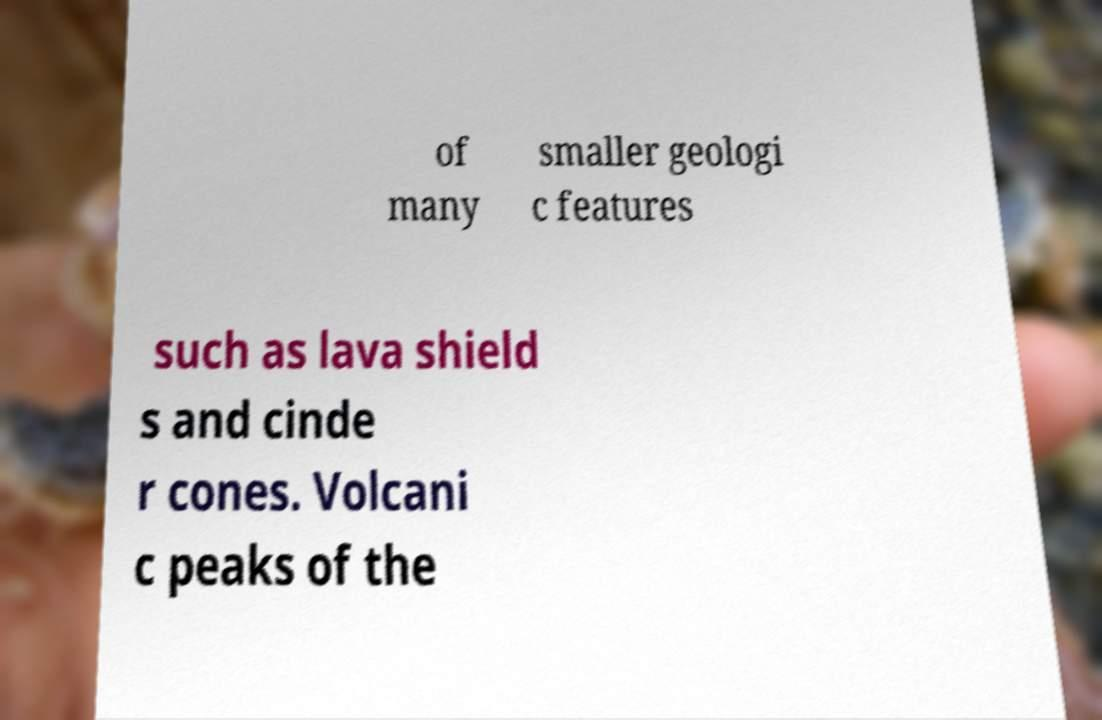Can you read and provide the text displayed in the image?This photo seems to have some interesting text. Can you extract and type it out for me? of many smaller geologi c features such as lava shield s and cinde r cones. Volcani c peaks of the 